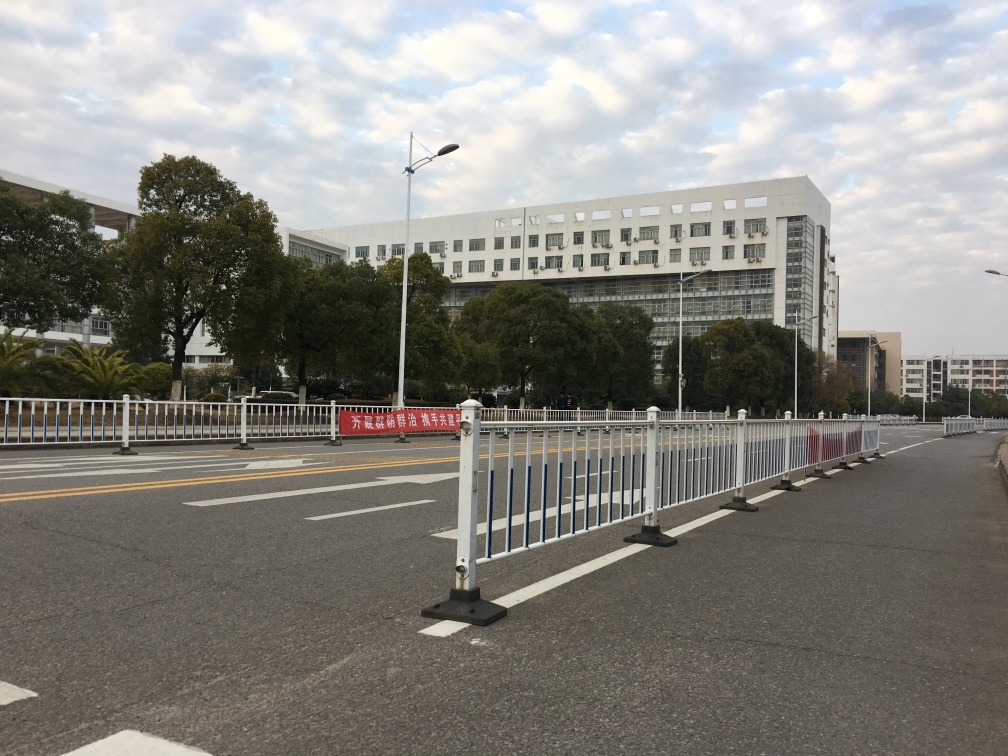Can you describe the weather conditions in this scene? The weather seems to be calm and overcast, with no visible signs of rain or strong winds. The clouds diffuse the sunlight, providing even lighting across the scene. 